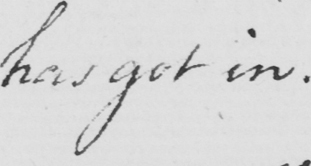Please transcribe the handwritten text in this image. has got in 